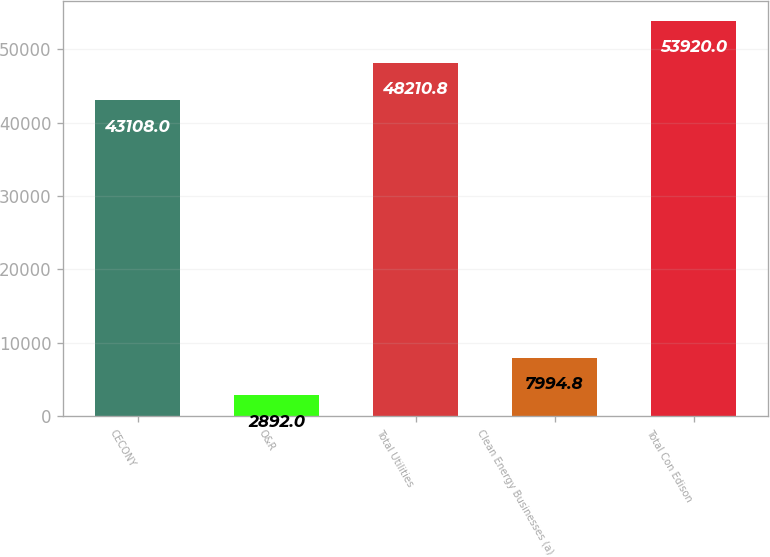Convert chart. <chart><loc_0><loc_0><loc_500><loc_500><bar_chart><fcel>CECONY<fcel>O&R<fcel>Total Utilities<fcel>Clean Energy Businesses (a)<fcel>Total Con Edison<nl><fcel>43108<fcel>2892<fcel>48210.8<fcel>7994.8<fcel>53920<nl></chart> 